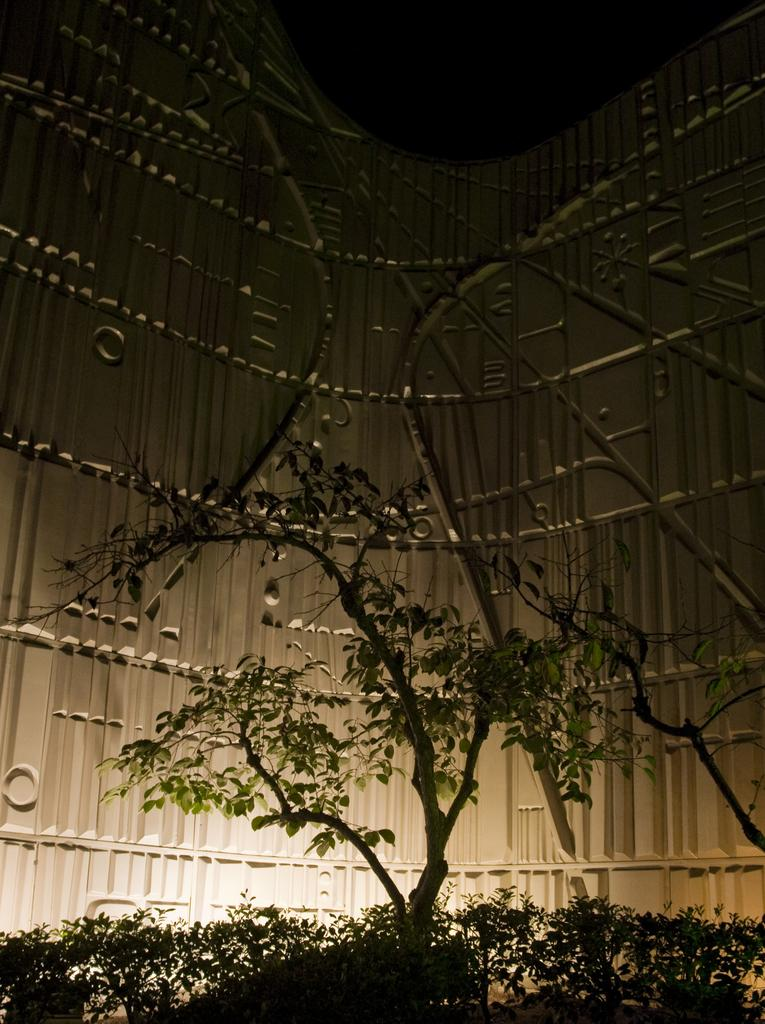What type of living organisms can be seen in the image? Plants and a tree are visible in the image. Can you describe the structure in the background of the image? There is a building wall visible in the background of the image. What type of fruit is hanging from the tree in the image? There is no fruit visible on the tree in the image. Can you describe the tramp performing tricks near the tree? There is no tramp or any indication of tricks being performed in the image. 